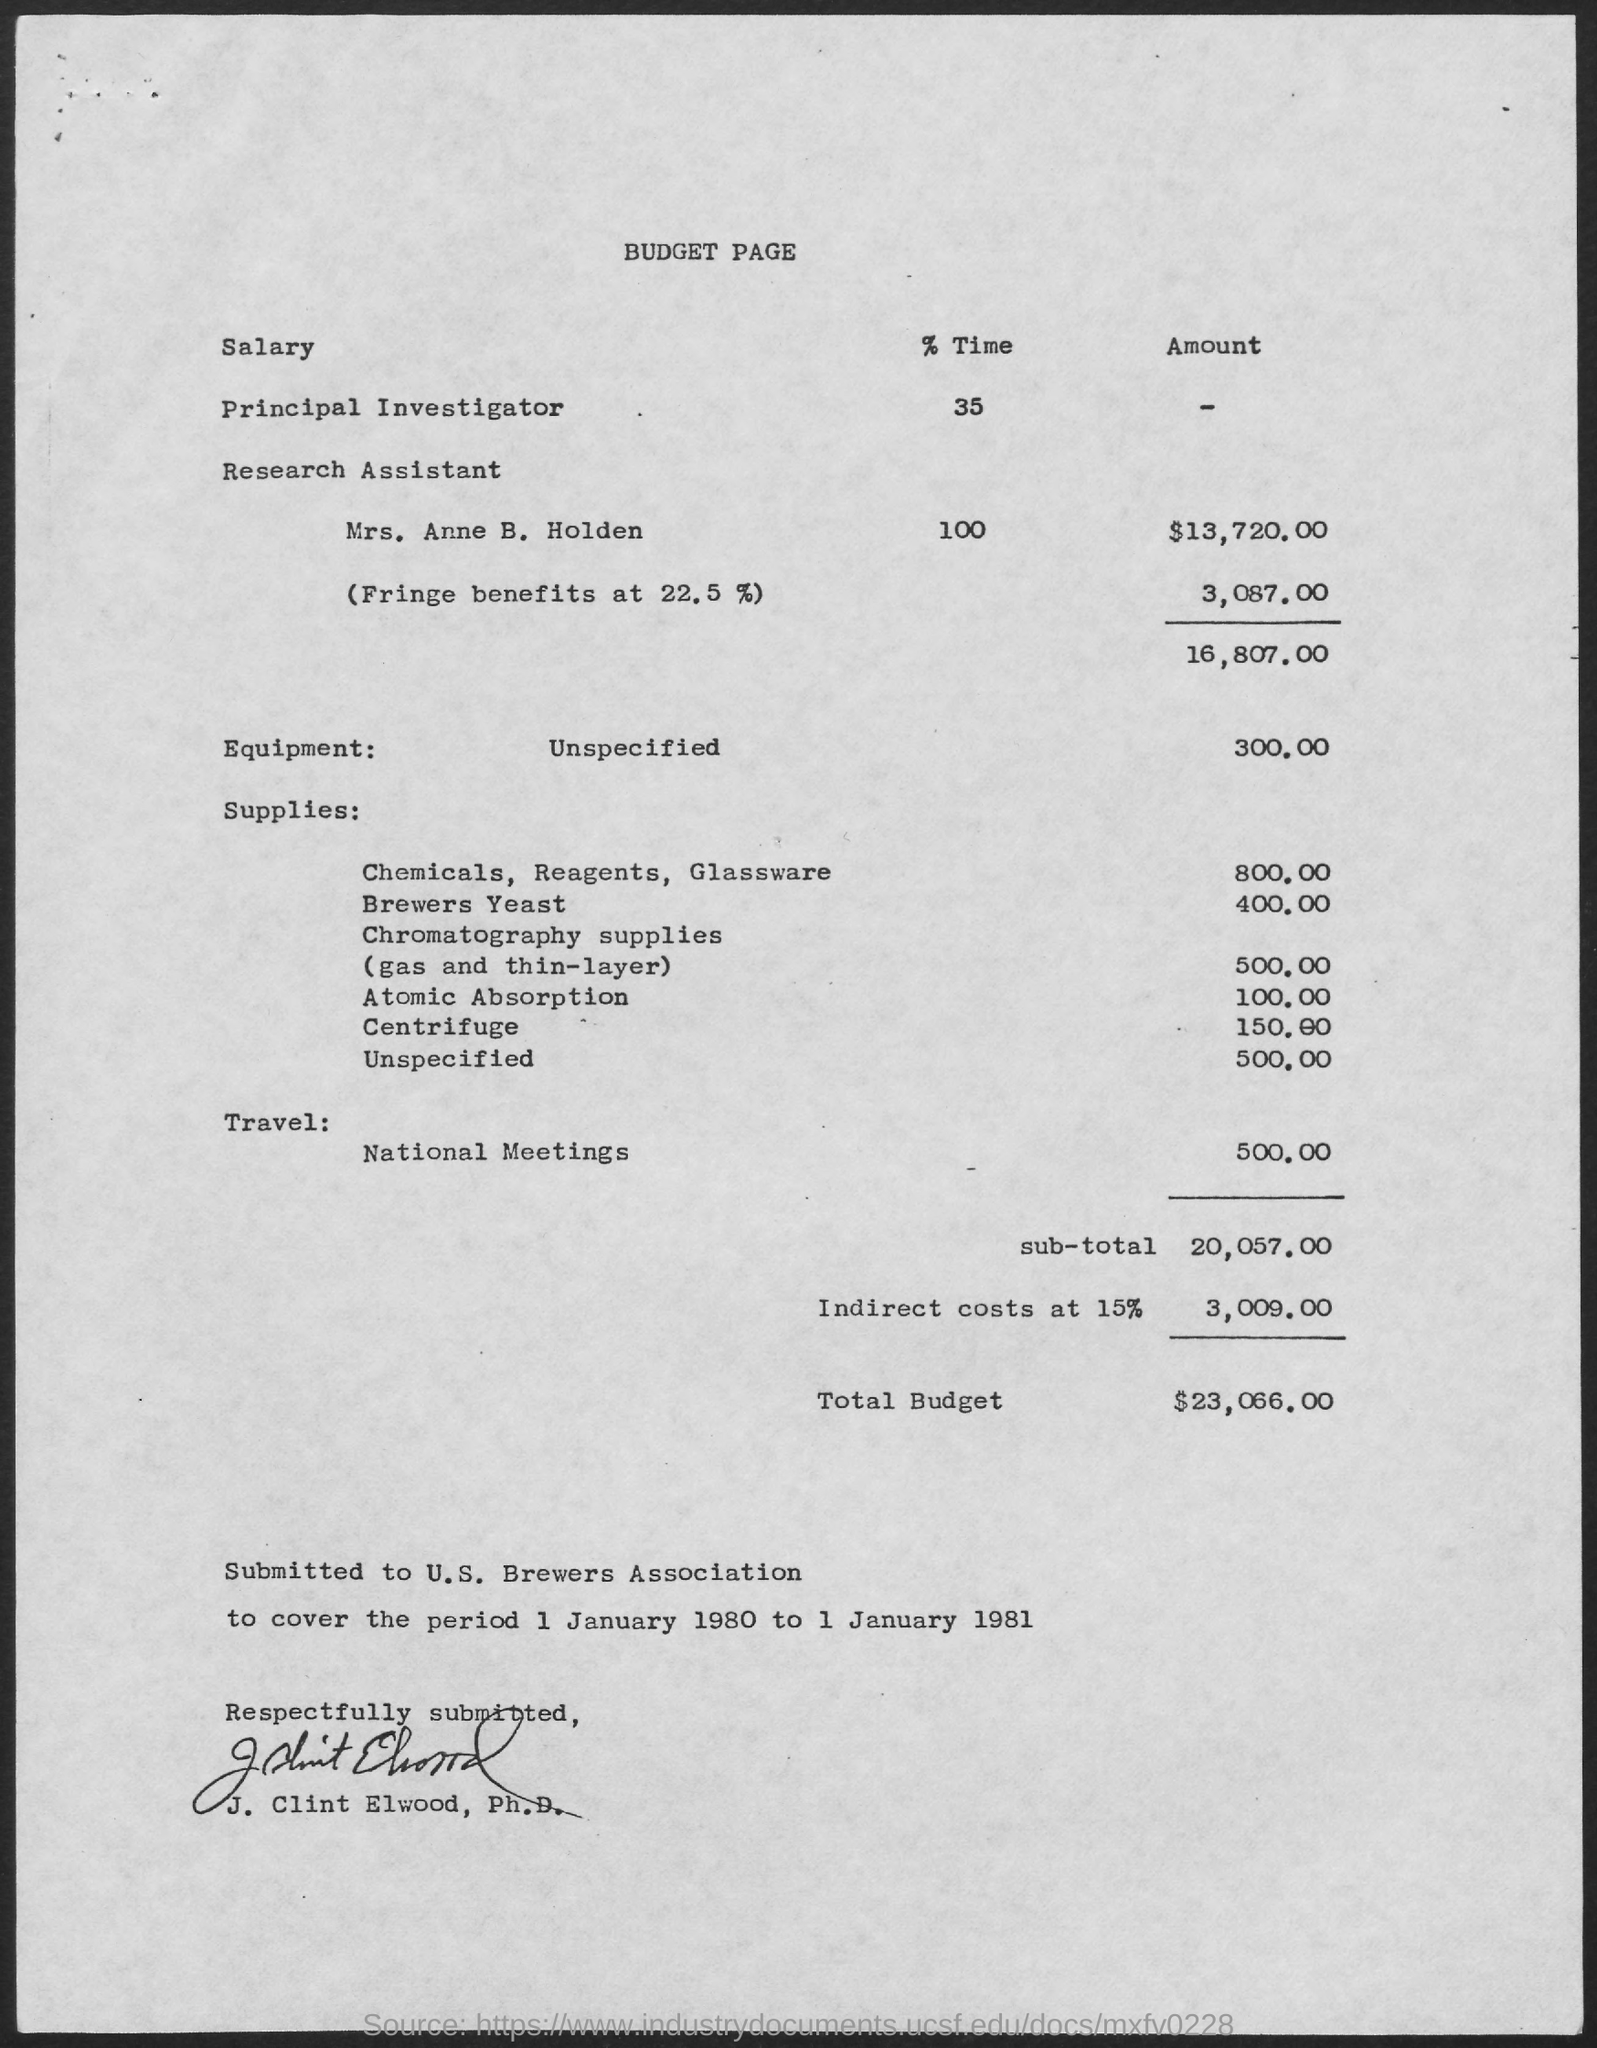Draw attention to some important aspects in this diagram. The heading of the page reads "Budget. The sub-total amount is 20,057.00. The U.S. Brewers Association covers the period of 1 January 1980 to 1 January 1981. The bill is submitted to the U.S. Brewers Association. The total budget is $23,066.00. 